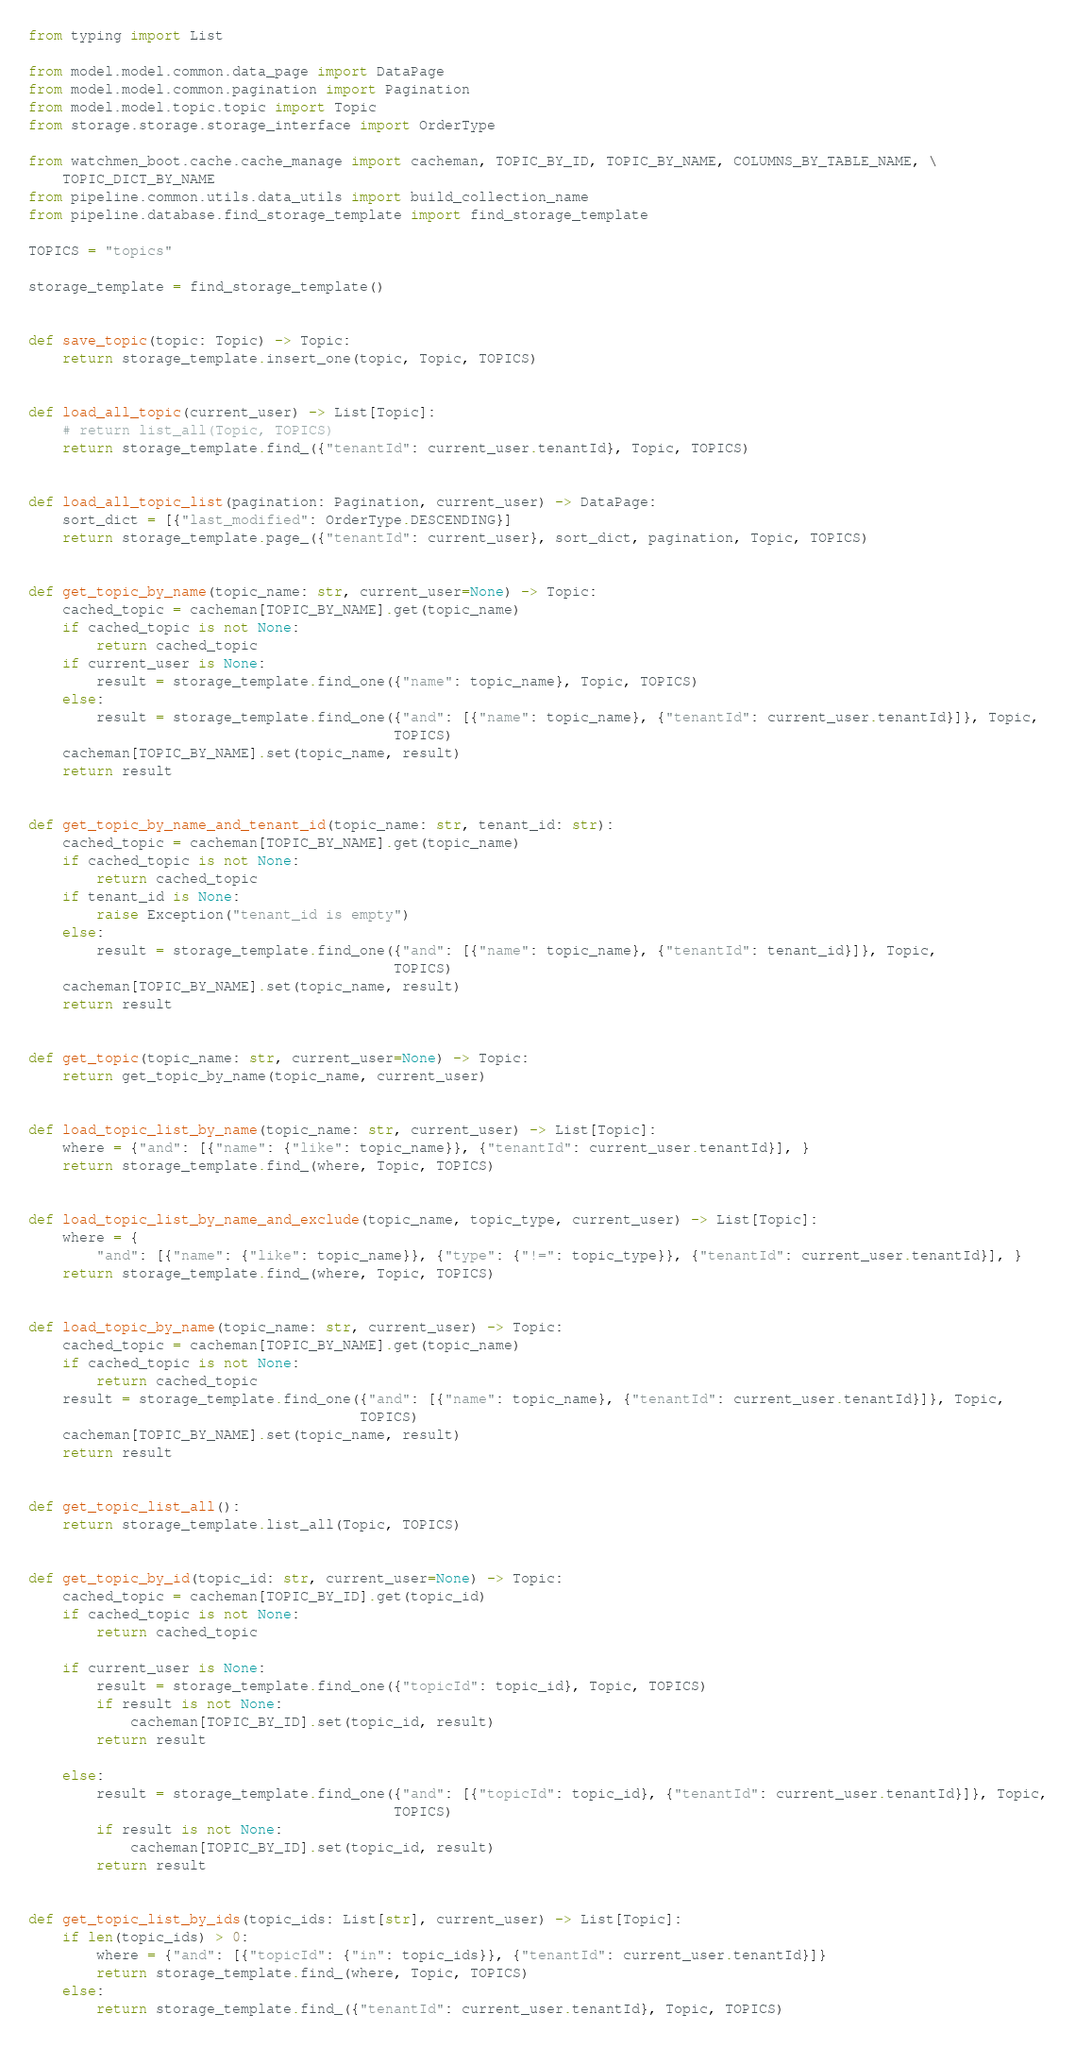<code> <loc_0><loc_0><loc_500><loc_500><_Python_>from typing import List

from model.model.common.data_page import DataPage
from model.model.common.pagination import Pagination
from model.model.topic.topic import Topic
from storage.storage.storage_interface import OrderType

from watchmen_boot.cache.cache_manage import cacheman, TOPIC_BY_ID, TOPIC_BY_NAME, COLUMNS_BY_TABLE_NAME, \
    TOPIC_DICT_BY_NAME
from pipeline.common.utils.data_utils import build_collection_name
from pipeline.database.find_storage_template import find_storage_template

TOPICS = "topics"

storage_template = find_storage_template()


def save_topic(topic: Topic) -> Topic:
    return storage_template.insert_one(topic, Topic, TOPICS)


def load_all_topic(current_user) -> List[Topic]:
    # return list_all(Topic, TOPICS)
    return storage_template.find_({"tenantId": current_user.tenantId}, Topic, TOPICS)


def load_all_topic_list(pagination: Pagination, current_user) -> DataPage:
    sort_dict = [{"last_modified": OrderType.DESCENDING}]
    return storage_template.page_({"tenantId": current_user}, sort_dict, pagination, Topic, TOPICS)


def get_topic_by_name(topic_name: str, current_user=None) -> Topic:
    cached_topic = cacheman[TOPIC_BY_NAME].get(topic_name)
    if cached_topic is not None:
        return cached_topic
    if current_user is None:
        result = storage_template.find_one({"name": topic_name}, Topic, TOPICS)
    else:
        result = storage_template.find_one({"and": [{"name": topic_name}, {"tenantId": current_user.tenantId}]}, Topic,
                                           TOPICS)
    cacheman[TOPIC_BY_NAME].set(topic_name, result)
    return result


def get_topic_by_name_and_tenant_id(topic_name: str, tenant_id: str):
    cached_topic = cacheman[TOPIC_BY_NAME].get(topic_name)
    if cached_topic is not None:
        return cached_topic
    if tenant_id is None:
        raise Exception("tenant_id is empty")
    else:
        result = storage_template.find_one({"and": [{"name": topic_name}, {"tenantId": tenant_id}]}, Topic,
                                           TOPICS)
    cacheman[TOPIC_BY_NAME].set(topic_name, result)
    return result


def get_topic(topic_name: str, current_user=None) -> Topic:
    return get_topic_by_name(topic_name, current_user)


def load_topic_list_by_name(topic_name: str, current_user) -> List[Topic]:
    where = {"and": [{"name": {"like": topic_name}}, {"tenantId": current_user.tenantId}], }
    return storage_template.find_(where, Topic, TOPICS)


def load_topic_list_by_name_and_exclude(topic_name, topic_type, current_user) -> List[Topic]:
    where = {
        "and": [{"name": {"like": topic_name}}, {"type": {"!=": topic_type}}, {"tenantId": current_user.tenantId}], }
    return storage_template.find_(where, Topic, TOPICS)


def load_topic_by_name(topic_name: str, current_user) -> Topic:
    cached_topic = cacheman[TOPIC_BY_NAME].get(topic_name)
    if cached_topic is not None:
        return cached_topic
    result = storage_template.find_one({"and": [{"name": topic_name}, {"tenantId": current_user.tenantId}]}, Topic,
                                       TOPICS)
    cacheman[TOPIC_BY_NAME].set(topic_name, result)
    return result


def get_topic_list_all():
    return storage_template.list_all(Topic, TOPICS)


def get_topic_by_id(topic_id: str, current_user=None) -> Topic:
    cached_topic = cacheman[TOPIC_BY_ID].get(topic_id)
    if cached_topic is not None:
        return cached_topic

    if current_user is None:
        result = storage_template.find_one({"topicId": topic_id}, Topic, TOPICS)
        if result is not None:
            cacheman[TOPIC_BY_ID].set(topic_id, result)
        return result

    else:
        result = storage_template.find_one({"and": [{"topicId": topic_id}, {"tenantId": current_user.tenantId}]}, Topic,
                                           TOPICS)
        if result is not None:
            cacheman[TOPIC_BY_ID].set(topic_id, result)
        return result


def get_topic_list_by_ids(topic_ids: List[str], current_user) -> List[Topic]:
    if len(topic_ids) > 0:
        where = {"and": [{"topicId": {"in": topic_ids}}, {"tenantId": current_user.tenantId}]}
        return storage_template.find_(where, Topic, TOPICS)
    else:
        return storage_template.find_({"tenantId": current_user.tenantId}, Topic, TOPICS)

</code> 